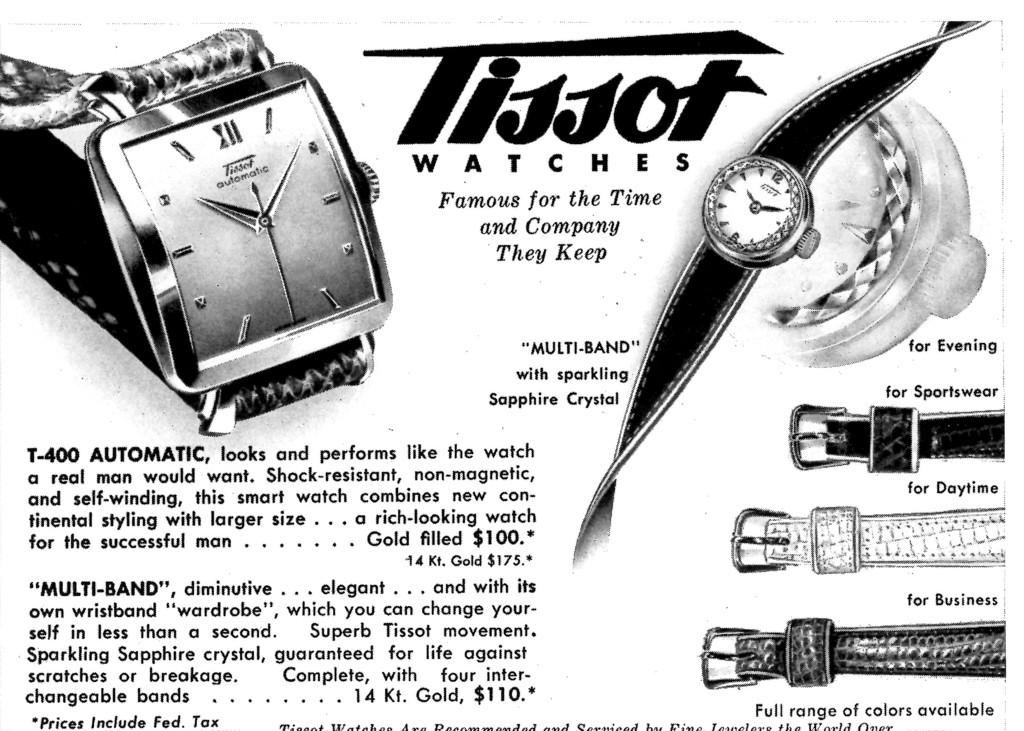<image>
Summarize the visual content of the image. An old ad for Tissot watches features both square and round watches. 